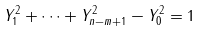Convert formula to latex. <formula><loc_0><loc_0><loc_500><loc_500>Y ^ { 2 } _ { 1 } + \cdots + Y ^ { 2 } _ { n - m + 1 } - Y ^ { 2 } _ { 0 } = 1</formula> 